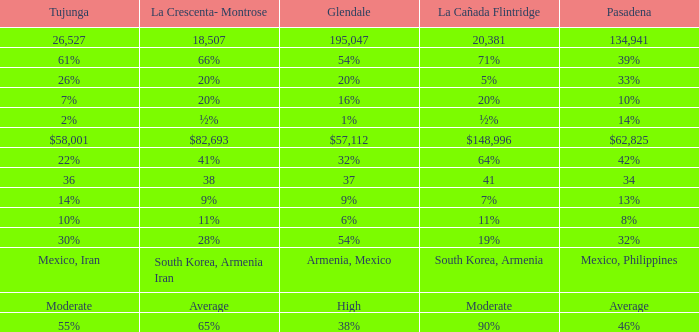Would you mind parsing the complete table? {'header': ['Tujunga', 'La Crescenta- Montrose', 'Glendale', 'La Cañada Flintridge', 'Pasadena'], 'rows': [['26,527', '18,507', '195,047', '20,381', '134,941'], ['61%', '66%', '54%', '71%', '39%'], ['26%', '20%', '20%', '5%', '33%'], ['7%', '20%', '16%', '20%', '10%'], ['2%', '½%', '1%', '½%', '14%'], ['$58,001', '$82,693', '$57,112', '$148,996', '$62,825'], ['22%', '41%', '32%', '64%', '42%'], ['36', '38', '37', '41', '34'], ['14%', '9%', '9%', '7%', '13%'], ['10%', '11%', '6%', '11%', '8%'], ['30%', '28%', '54%', '19%', '32%'], ['Mexico, Iran', 'South Korea, Armenia Iran', 'Armenia, Mexico', 'South Korea, Armenia', 'Mexico, Philippines'], ['Moderate', 'Average', 'High', 'Moderate', 'Average'], ['55%', '65%', '38%', '90%', '46%']]} What is tukunga's percentage when la crescenta-montrose accounts for 28%? 30%. 